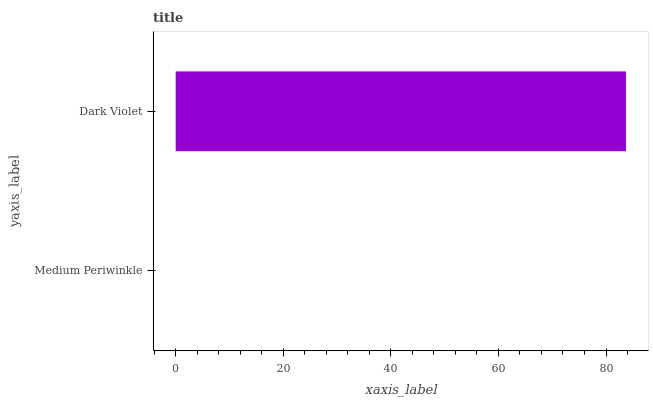Is Medium Periwinkle the minimum?
Answer yes or no. Yes. Is Dark Violet the maximum?
Answer yes or no. Yes. Is Dark Violet the minimum?
Answer yes or no. No. Is Dark Violet greater than Medium Periwinkle?
Answer yes or no. Yes. Is Medium Periwinkle less than Dark Violet?
Answer yes or no. Yes. Is Medium Periwinkle greater than Dark Violet?
Answer yes or no. No. Is Dark Violet less than Medium Periwinkle?
Answer yes or no. No. Is Dark Violet the high median?
Answer yes or no. Yes. Is Medium Periwinkle the low median?
Answer yes or no. Yes. Is Medium Periwinkle the high median?
Answer yes or no. No. Is Dark Violet the low median?
Answer yes or no. No. 